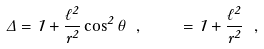<formula> <loc_0><loc_0><loc_500><loc_500>\Delta = 1 + \frac { \ell ^ { 2 } } { r ^ { 2 } } \cos ^ { 2 } \theta \ , \quad \Xi = 1 + \frac { \ell ^ { 2 } } { r ^ { 2 } } \ , \label l { p a r a m s }</formula> 